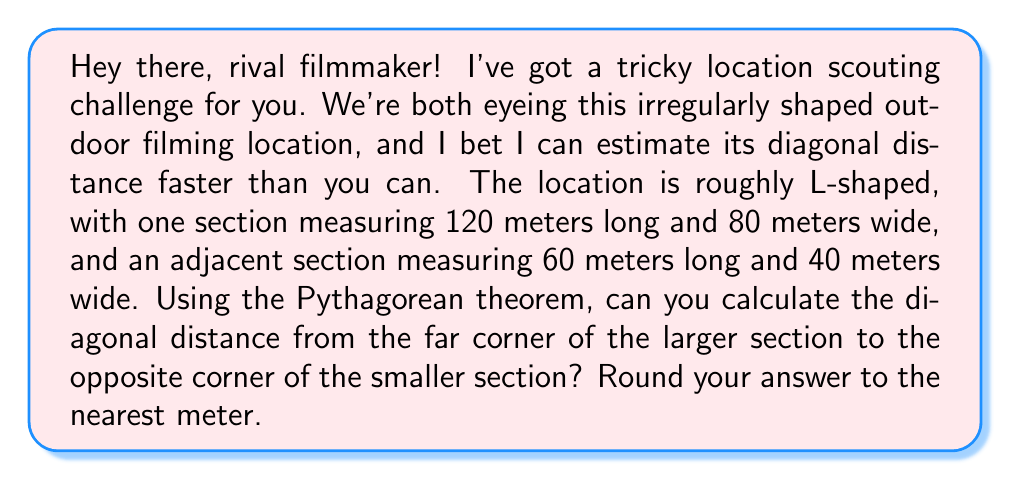Solve this math problem. Let's approach this step-by-step:

1) First, we need to visualize the L-shaped area:

[asy]
unitsize(1cm);
draw((0,0)--(12,0)--(12,8)--(6,8)--(6,12)--(0,12)--cycle);
label("120m", (6,0), S);
label("80m", (12,4), E);
label("60m", (3,10), W);
label("40m", (6,10), S);
draw((0,12)--(12,8), dashed);
[/asy]

2) To find the diagonal, we can treat this as a right triangle where:
   - The base is the full length of the L-shape (120m + 60m = 180m)
   - The height is the full height of the L-shape (80m)

3) Now we can apply the Pythagorean theorem: $a^2 + b^2 = c^2$
   Where $c$ is our diagonal distance.

4) Plugging in our values:
   $180^2 + 80^2 = c^2$

5) Let's calculate:
   $32400 + 6400 = c^2$
   $38800 = c^2$

6) To find $c$, we take the square root of both sides:
   $c = \sqrt{38800}$

7) Using a calculator:
   $c \approx 196.98$ meters

8) Rounding to the nearest meter:
   $c \approx 197$ meters
Answer: 197 meters 